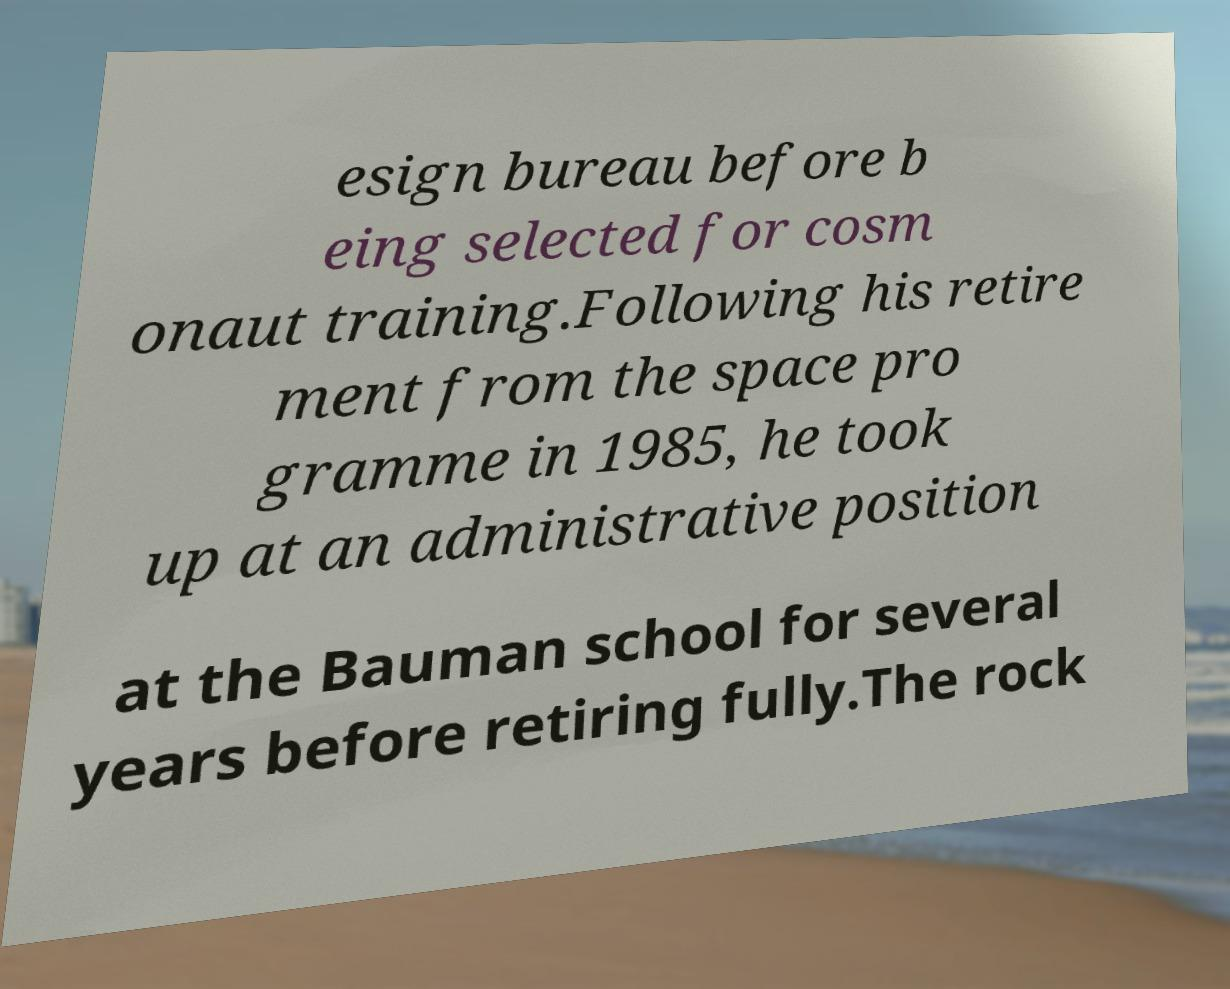For documentation purposes, I need the text within this image transcribed. Could you provide that? esign bureau before b eing selected for cosm onaut training.Following his retire ment from the space pro gramme in 1985, he took up at an administrative position at the Bauman school for several years before retiring fully.The rock 